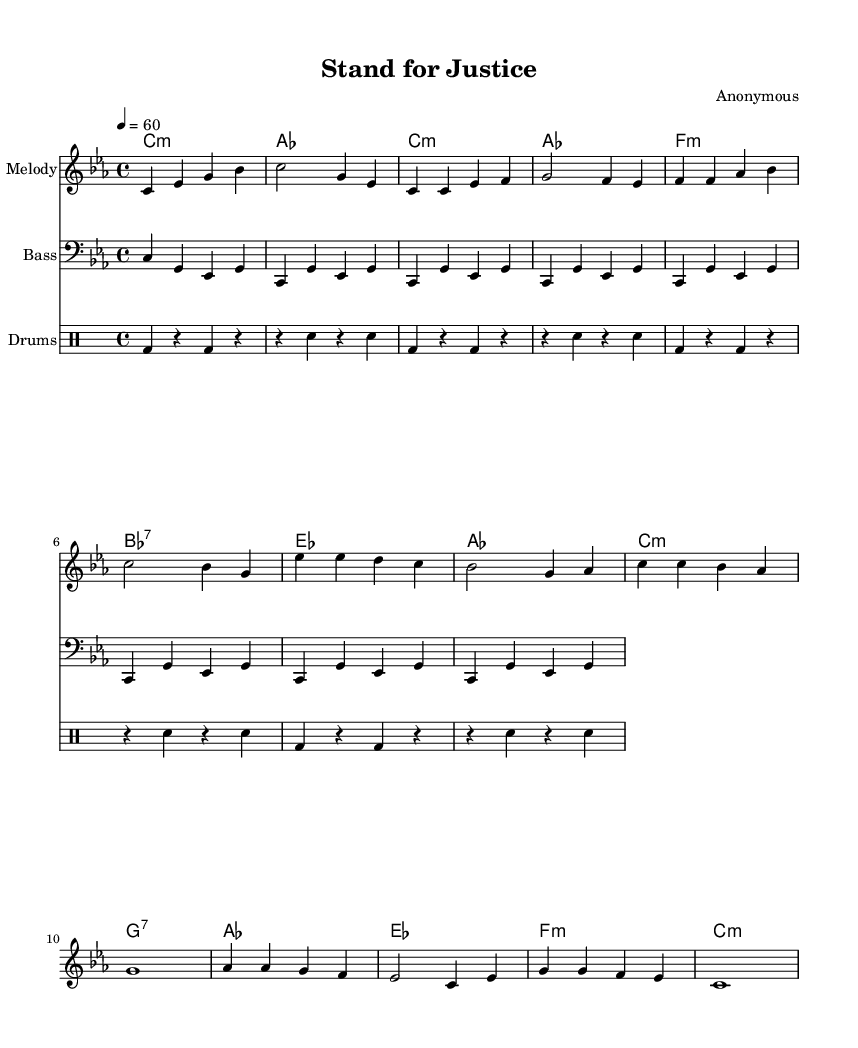What is the key signature of this music? The key signature is indicated after the \key command, which shows it is in C minor. C minor has three flats.
Answer: C minor What is the time signature of this music? The time signature is specified in the \time command, which shows it is in 4/4 time, meaning there are four beats per measure.
Answer: 4/4 What is the tempo marking for this piece? The tempo is indicated by the \tempo command, which sets the speed to a quarter note equaling sixty beats per minute.
Answer: 60 How many measures are in the chorus section? To determine this, you can count the number of distinct measures in the chorus. The chorus has four measures as indicated by the melody section.
Answer: 4 What chord is played during the intro? The chord played in the intro is specified in the harmonies section. The first chord is C minor.
Answer: C minor What type of drums are used in this piece? The drumming style is outlined in the \drummode section, reflecting typical rhythm and blues patterns. The specific notation denotes a standard drum set with bass and snare.
Answer: Standard drum set What is the lyrical theme of the song? Analyzing the lyrics in the text section reveals the theme revolves around justice, equality, and standing against injustice.
Answer: Justice and equality 